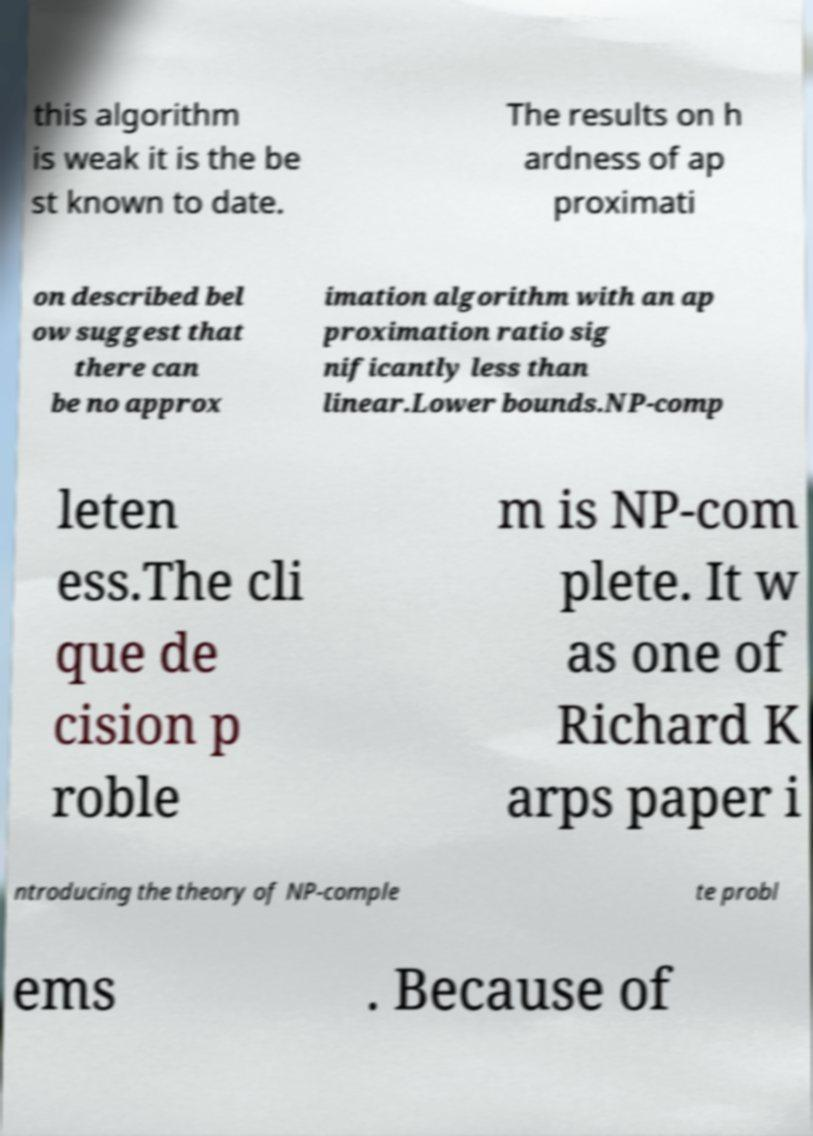Could you extract and type out the text from this image? this algorithm is weak it is the be st known to date. The results on h ardness of ap proximati on described bel ow suggest that there can be no approx imation algorithm with an ap proximation ratio sig nificantly less than linear.Lower bounds.NP-comp leten ess.The cli que de cision p roble m is NP-com plete. It w as one of Richard K arps paper i ntroducing the theory of NP-comple te probl ems . Because of 